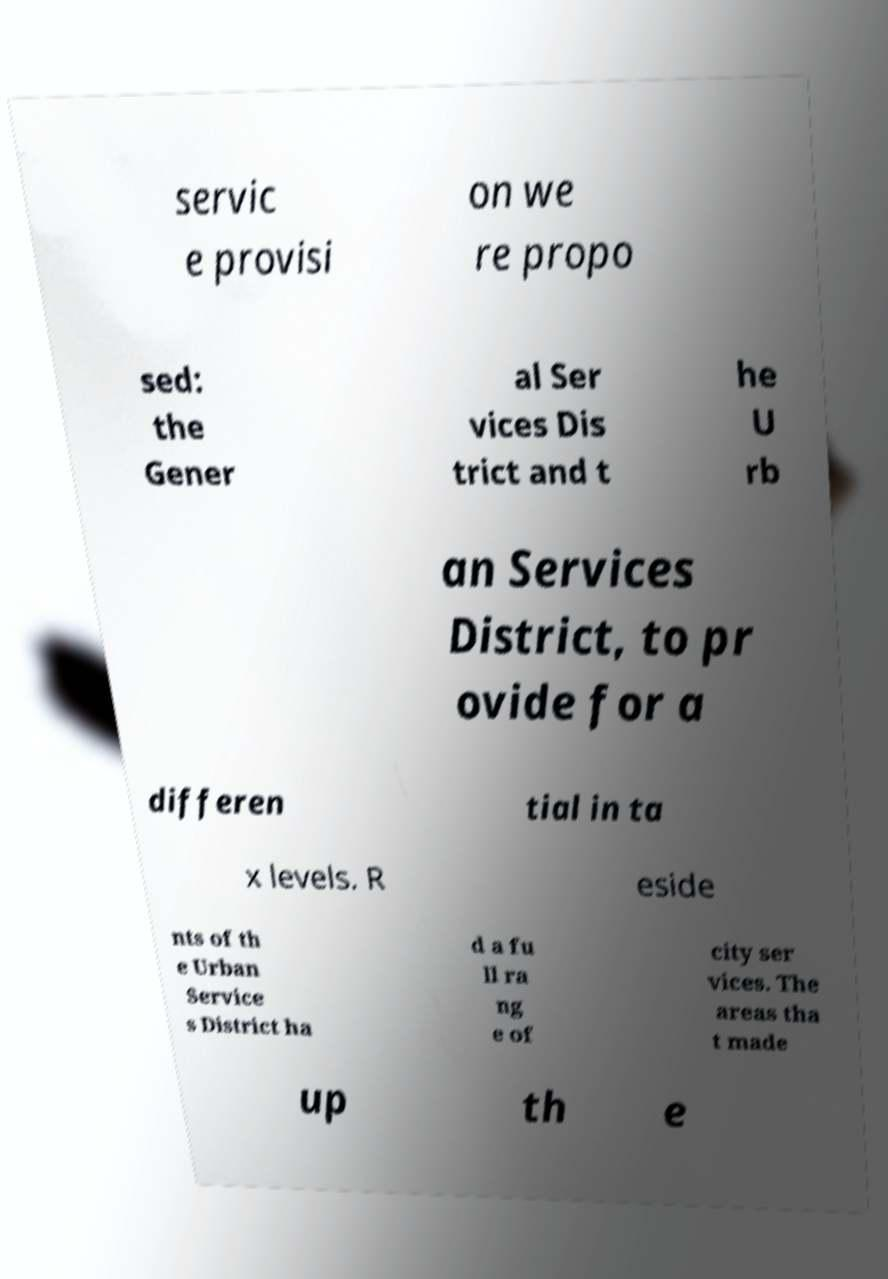Please identify and transcribe the text found in this image. servic e provisi on we re propo sed: the Gener al Ser vices Dis trict and t he U rb an Services District, to pr ovide for a differen tial in ta x levels. R eside nts of th e Urban Service s District ha d a fu ll ra ng e of city ser vices. The areas tha t made up th e 